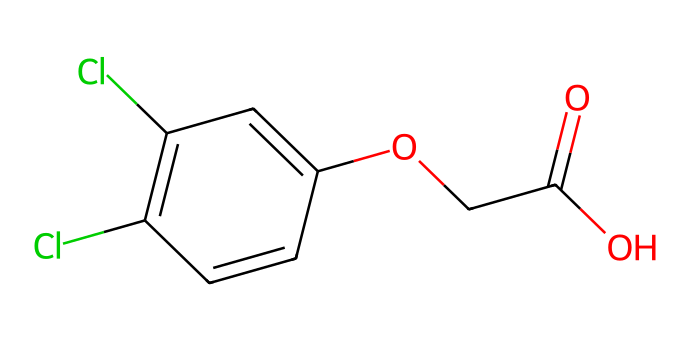What is the molecular formula of 2,4-Dichlorophenoxyacetic acid? To derive the molecular formula, count the number of each type of atom in the SMILES representation. There are 8 carbon (C) atoms, 6 hydrogen (H) atoms, 2 chlorine (Cl) atoms, 3 oxygen (O) atoms, leading to the formula C8H6Cl2O3.
Answer: C8H6Cl2O3 How many rings are present in the structure? Analyzing the SMILES structure, we recognize that the "C1" notation indicates a ring structure. There is one complete ring formed by the carbon atoms in the benzene-like structure.
Answer: 1 What type of functional group is present in 2,4-D? Observing the structure, we identify the presence of a carboxylic acid functional group (-COOH), which is characterized by a carbonyl (C=O) and a hydroxyl (O-H) group.
Answer: carboxylic acid How many chlorine atoms are attached to the aromatic ring? By examining the structure, we note that two chlorine (Cl) atoms are attached to the aromatic ring, specifically at the 2 and 4 positions on the benzene derivative.
Answer: 2 What is the primary use of 2,4-Dichlorophenoxyacetic acid? 2,4-D is primarily used as a selective herbicide, targeting broadleaf weeds while minimizing damage to grasses and other desired plants.
Answer: herbicide Is 2,4-D considered a systemic herbicide? 2,4-D operates primarily as a foliar herbicide, affecting the plant's growth systems when absorbed through leaves rather than being systemic throughout all parts.
Answer: no 